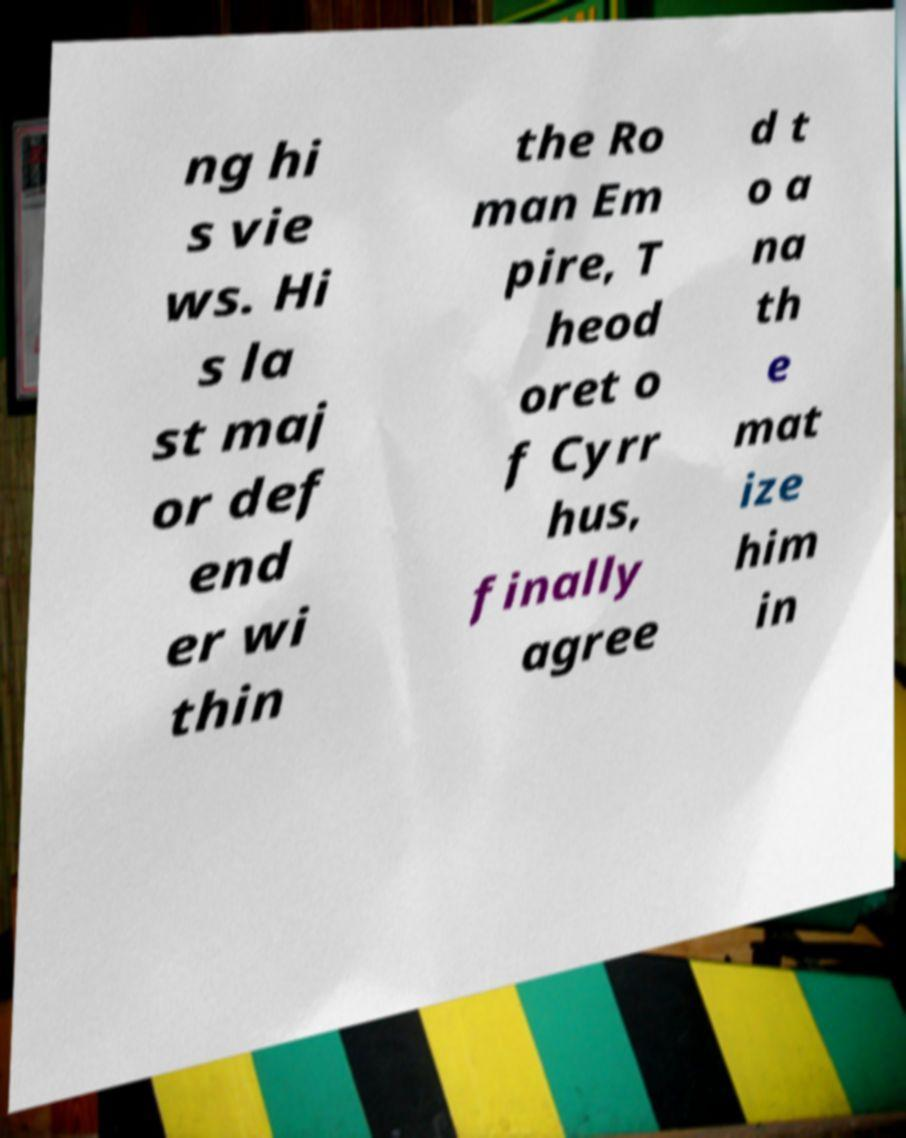Please identify and transcribe the text found in this image. ng hi s vie ws. Hi s la st maj or def end er wi thin the Ro man Em pire, T heod oret o f Cyrr hus, finally agree d t o a na th e mat ize him in 